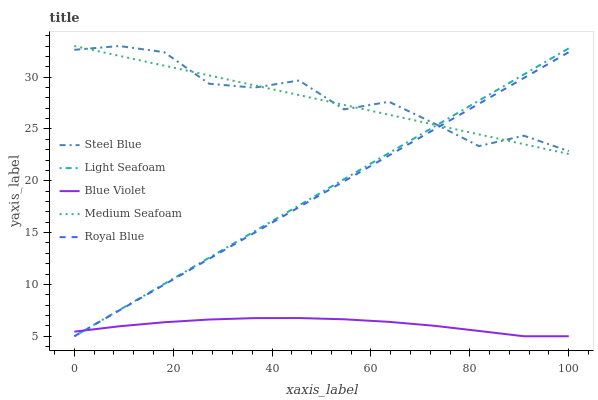Does Blue Violet have the minimum area under the curve?
Answer yes or no. Yes. Does Steel Blue have the maximum area under the curve?
Answer yes or no. Yes. Does Light Seafoam have the minimum area under the curve?
Answer yes or no. No. Does Light Seafoam have the maximum area under the curve?
Answer yes or no. No. Is Light Seafoam the smoothest?
Answer yes or no. Yes. Is Steel Blue the roughest?
Answer yes or no. Yes. Is Steel Blue the smoothest?
Answer yes or no. No. Is Light Seafoam the roughest?
Answer yes or no. No. Does Royal Blue have the lowest value?
Answer yes or no. Yes. Does Steel Blue have the lowest value?
Answer yes or no. No. Does Medium Seafoam have the highest value?
Answer yes or no. Yes. Does Light Seafoam have the highest value?
Answer yes or no. No. Is Blue Violet less than Steel Blue?
Answer yes or no. Yes. Is Steel Blue greater than Blue Violet?
Answer yes or no. Yes. Does Light Seafoam intersect Steel Blue?
Answer yes or no. Yes. Is Light Seafoam less than Steel Blue?
Answer yes or no. No. Is Light Seafoam greater than Steel Blue?
Answer yes or no. No. Does Blue Violet intersect Steel Blue?
Answer yes or no. No. 